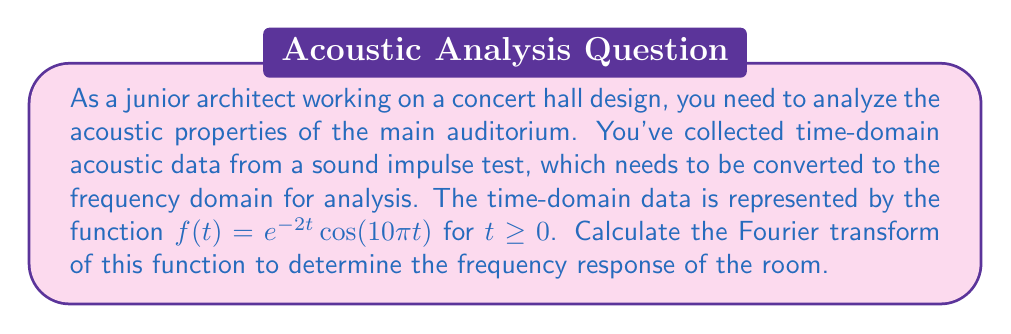Can you solve this math problem? To solve this problem, we need to apply the Fourier transform to the given time-domain function. Let's break it down step-by-step:

1) The Fourier transform of a function $f(t)$ is defined as:

   $$F(\omega) = \int_{-\infty}^{\infty} f(t) e^{-i\omega t} dt$$

2) In our case, $f(t) = e^{-2t}\cos(10\pi t)$ for $t \geq 0$, and $f(t) = 0$ for $t < 0$. So we can rewrite our integral as:

   $$F(\omega) = \int_{0}^{\infty} e^{-2t}\cos(10\pi t) e^{-i\omega t} dt$$

3) We can use Euler's formula to express the cosine term:

   $$\cos(10\pi t) = \frac{e^{i10\pi t} + e^{-i10\pi t}}{2}$$

4) Substituting this into our integral:

   $$F(\omega) = \frac{1}{2}\int_{0}^{\infty} e^{-2t}(e^{i10\pi t} + e^{-i10\pi t}) e^{-i\omega t} dt$$

5) This can be separated into two integrals:

   $$F(\omega) = \frac{1}{2}\int_{0}^{\infty} e^{-2t}e^{i10\pi t}e^{-i\omega t} dt + \frac{1}{2}\int_{0}^{\infty} e^{-2t}e^{-i10\pi t}e^{-i\omega t} dt$$

6) Simplifying the exponents:

   $$F(\omega) = \frac{1}{2}\int_{0}^{\infty} e^{-(2+i\omega-i10\pi)t} dt + \frac{1}{2}\int_{0}^{\infty} e^{-(2+i\omega+i10\pi)t} dt$$

7) These integrals have the form $\int_{0}^{\infty} e^{-at} dt = \frac{1}{a}$ for $Re(a) > 0$. Applying this:

   $$F(\omega) = \frac{1}{2}\left[\frac{1}{2+i(\omega-10\pi)} + \frac{1}{2+i(\omega+10\pi)}\right]$$

8) Finding a common denominator:

   $$F(\omega) = \frac{2+i(\omega-10\pi) + 2+i(\omega+10\pi)}{2[(2+i(\omega-10\pi))(2+i(\omega+10\pi))]}$$

9) Simplifying:

   $$F(\omega) = \frac{4+2i\omega}{2[4-\omega^2+20\pi\omega-100\pi^2+4i\omega]}$$

10) Further simplification:

    $$F(\omega) = \frac{2+i\omega}{4+20\pi\omega-\omega^2-100\pi^2+4i\omega}$$

This is the Fourier transform of the given time-domain function, representing the frequency response of the room.
Answer: $$F(\omega) = \frac{2+i\omega}{4+20\pi\omega-\omega^2-100\pi^2+4i\omega}$$ 